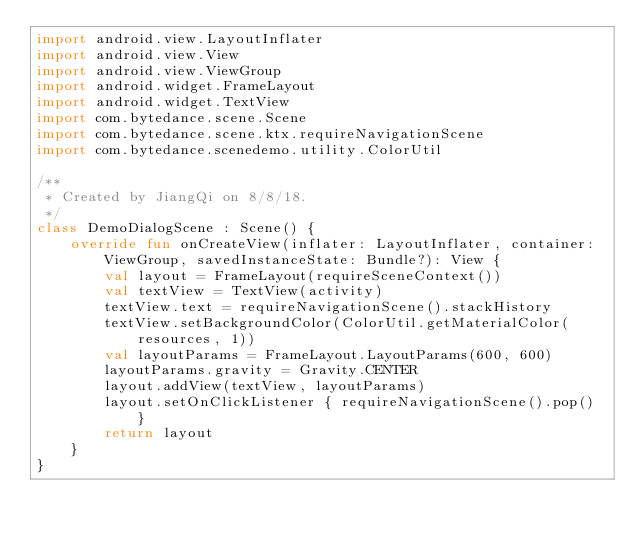<code> <loc_0><loc_0><loc_500><loc_500><_Kotlin_>import android.view.LayoutInflater
import android.view.View
import android.view.ViewGroup
import android.widget.FrameLayout
import android.widget.TextView
import com.bytedance.scene.Scene
import com.bytedance.scene.ktx.requireNavigationScene
import com.bytedance.scenedemo.utility.ColorUtil

/**
 * Created by JiangQi on 8/8/18.
 */
class DemoDialogScene : Scene() {
    override fun onCreateView(inflater: LayoutInflater, container: ViewGroup, savedInstanceState: Bundle?): View {
        val layout = FrameLayout(requireSceneContext())
        val textView = TextView(activity)
        textView.text = requireNavigationScene().stackHistory
        textView.setBackgroundColor(ColorUtil.getMaterialColor(resources, 1))
        val layoutParams = FrameLayout.LayoutParams(600, 600)
        layoutParams.gravity = Gravity.CENTER
        layout.addView(textView, layoutParams)
        layout.setOnClickListener { requireNavigationScene().pop() }
        return layout
    }
}</code> 